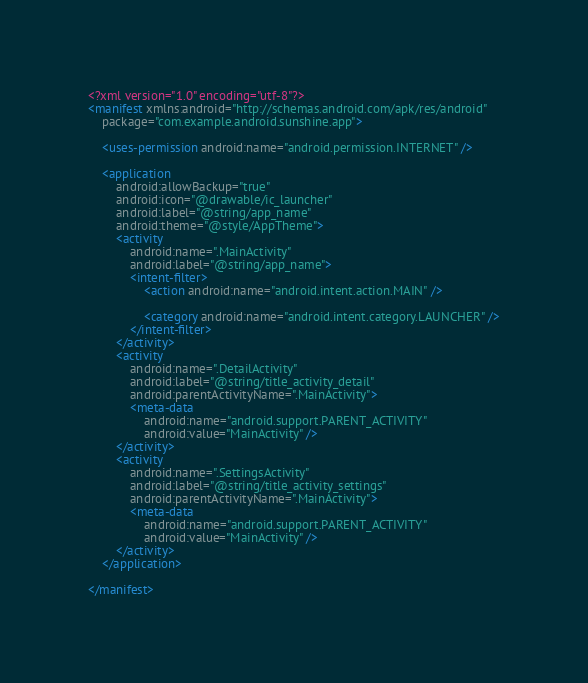Convert code to text. <code><loc_0><loc_0><loc_500><loc_500><_XML_><?xml version="1.0" encoding="utf-8"?>
<manifest xmlns:android="http://schemas.android.com/apk/res/android"
    package="com.example.android.sunshine.app">

    <uses-permission android:name="android.permission.INTERNET" />

    <application
        android:allowBackup="true"
        android:icon="@drawable/ic_launcher"
        android:label="@string/app_name"
        android:theme="@style/AppTheme">
        <activity
            android:name=".MainActivity"
            android:label="@string/app_name">
            <intent-filter>
                <action android:name="android.intent.action.MAIN" />

                <category android:name="android.intent.category.LAUNCHER" />
            </intent-filter>
        </activity>
        <activity
            android:name=".DetailActivity"
            android:label="@string/title_activity_detail"
            android:parentActivityName=".MainActivity">
            <meta-data
                android:name="android.support.PARENT_ACTIVITY"
                android:value="MainActivity" />
        </activity>
        <activity
            android:name=".SettingsActivity"
            android:label="@string/title_activity_settings"
            android:parentActivityName=".MainActivity">
            <meta-data
                android:name="android.support.PARENT_ACTIVITY"
                android:value="MainActivity" />
        </activity>
    </application>

</manifest></code> 